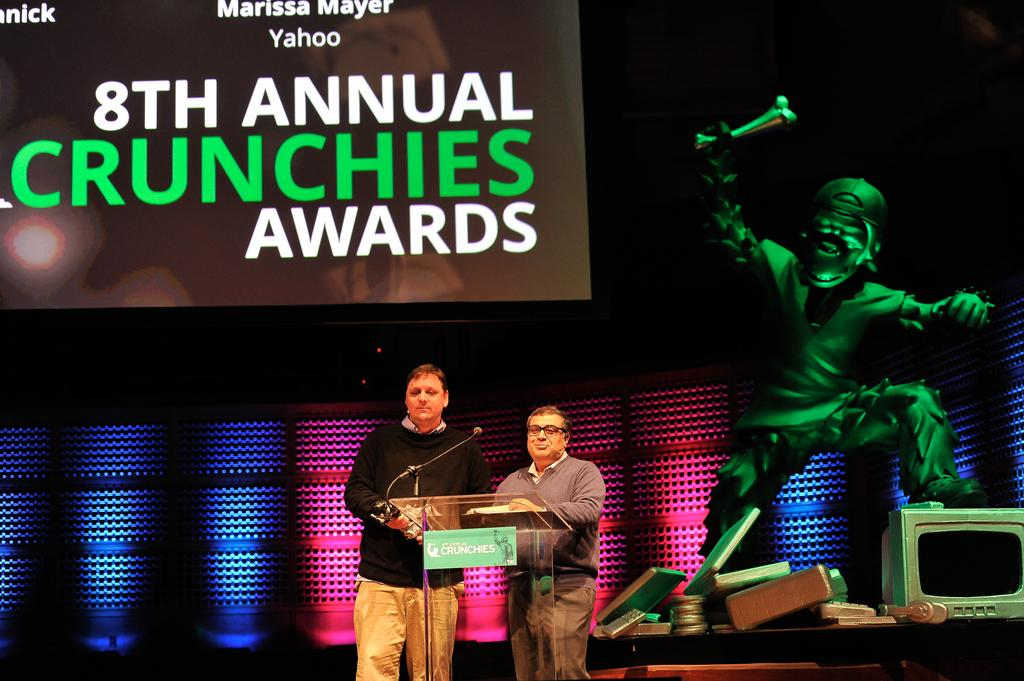Provide a one-sentence caption for the provided image. Two men standing on stage at a podium during the 8th Annual Crunchies Awards. 